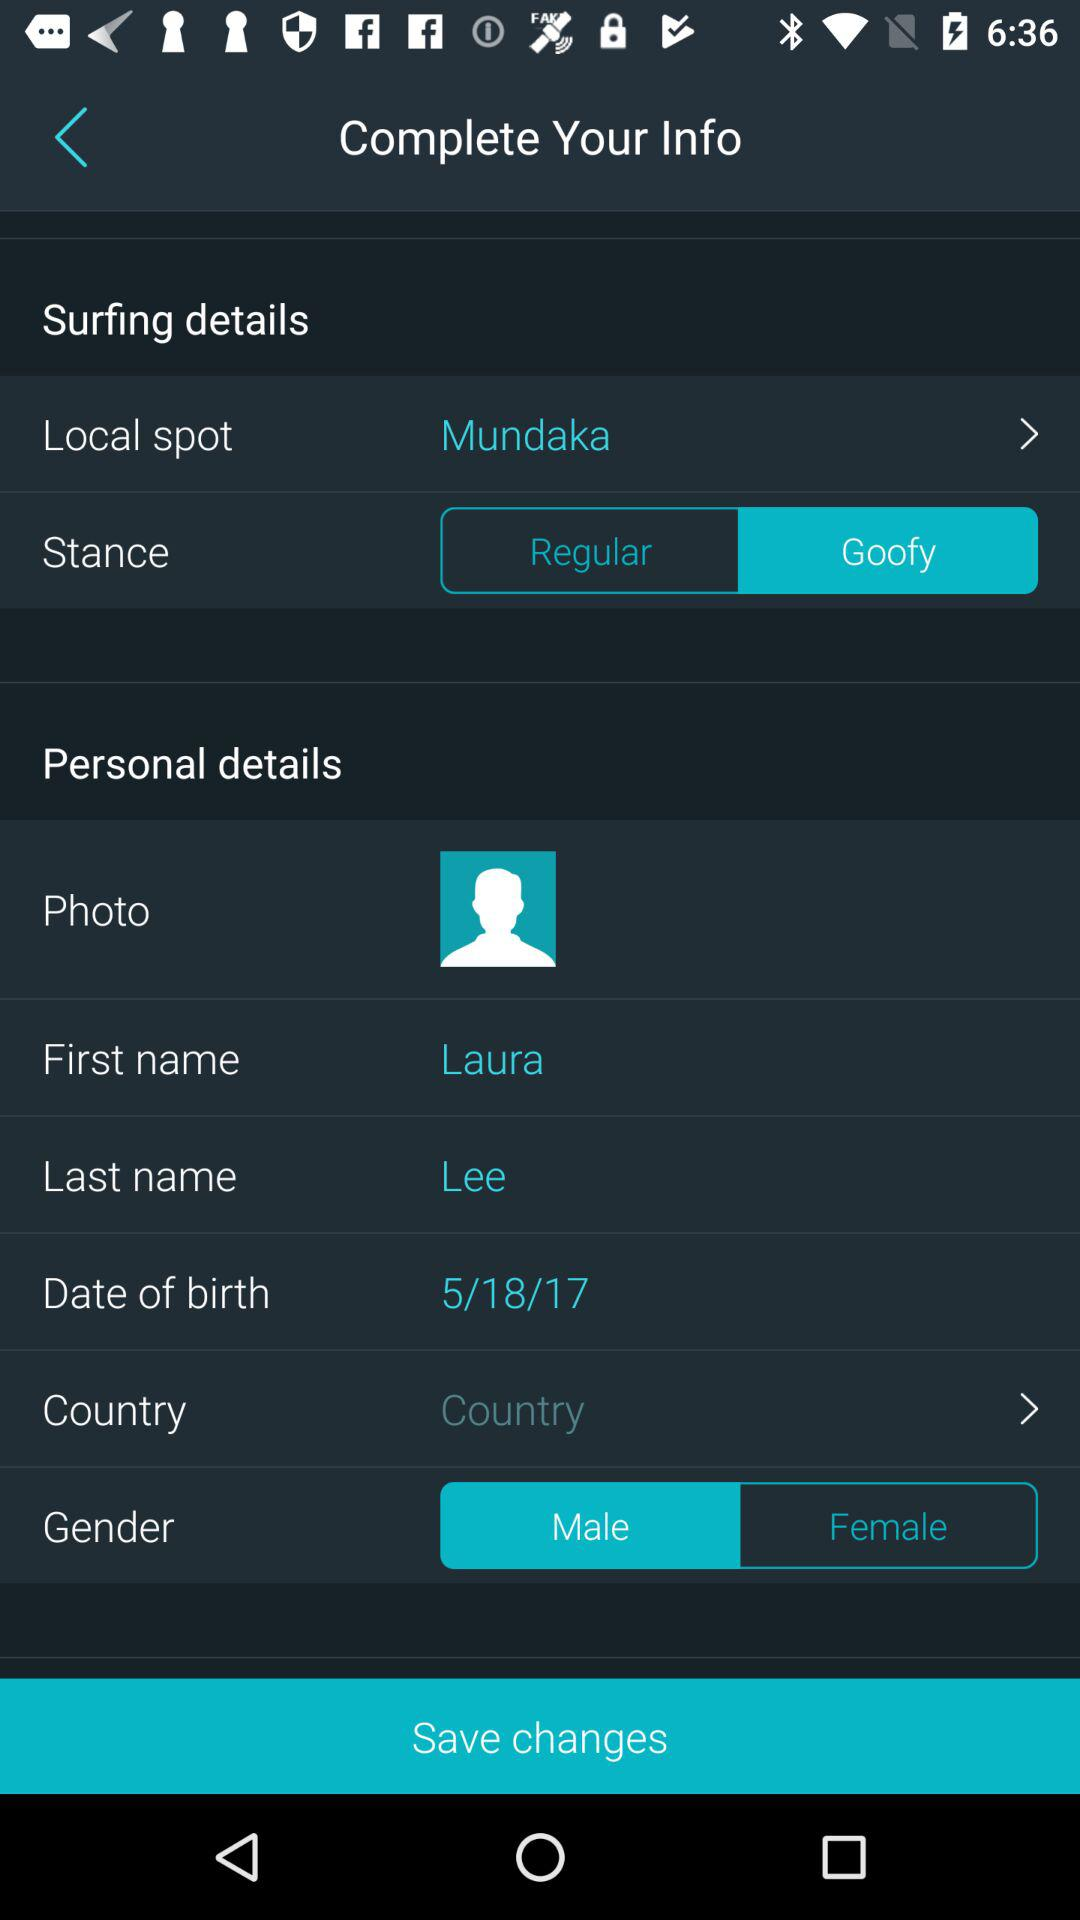What is the first name? The first name is Laura. 